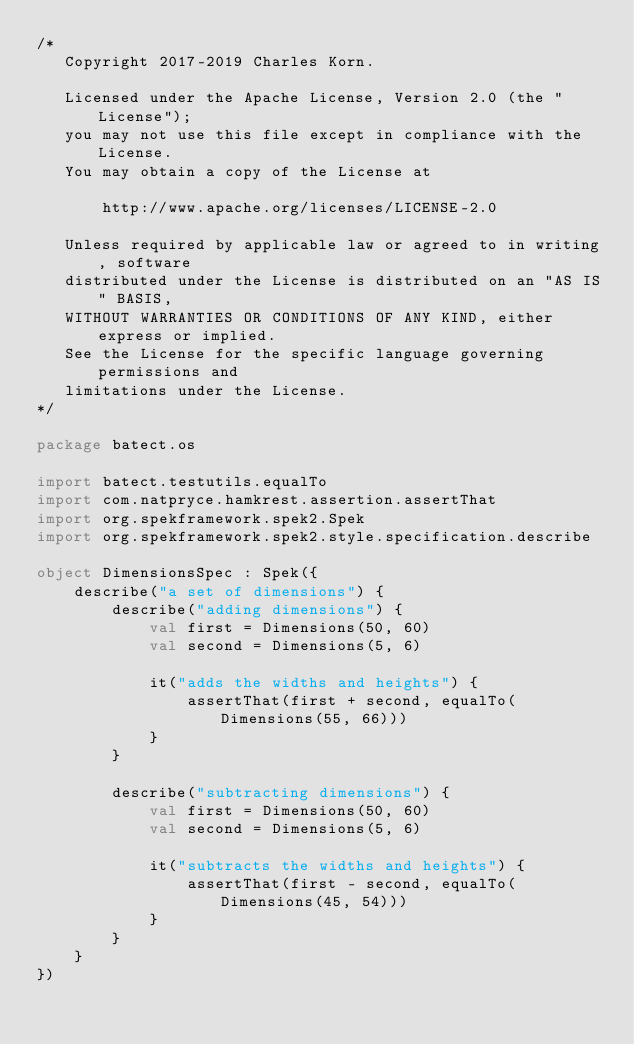<code> <loc_0><loc_0><loc_500><loc_500><_Kotlin_>/*
   Copyright 2017-2019 Charles Korn.

   Licensed under the Apache License, Version 2.0 (the "License");
   you may not use this file except in compliance with the License.
   You may obtain a copy of the License at

       http://www.apache.org/licenses/LICENSE-2.0

   Unless required by applicable law or agreed to in writing, software
   distributed under the License is distributed on an "AS IS" BASIS,
   WITHOUT WARRANTIES OR CONDITIONS OF ANY KIND, either express or implied.
   See the License for the specific language governing permissions and
   limitations under the License.
*/

package batect.os

import batect.testutils.equalTo
import com.natpryce.hamkrest.assertion.assertThat
import org.spekframework.spek2.Spek
import org.spekframework.spek2.style.specification.describe

object DimensionsSpec : Spek({
    describe("a set of dimensions") {
        describe("adding dimensions") {
            val first = Dimensions(50, 60)
            val second = Dimensions(5, 6)

            it("adds the widths and heights") {
                assertThat(first + second, equalTo(Dimensions(55, 66)))
            }
        }

        describe("subtracting dimensions") {
            val first = Dimensions(50, 60)
            val second = Dimensions(5, 6)

            it("subtracts the widths and heights") {
                assertThat(first - second, equalTo(Dimensions(45, 54)))
            }
        }
    }
})
</code> 